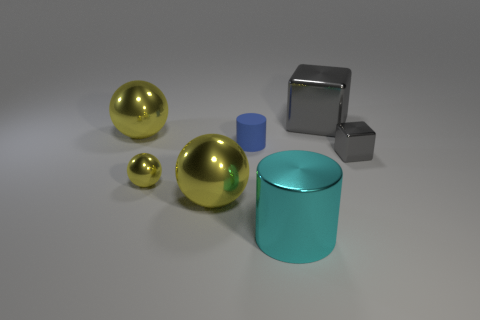What is the color of the cylinder that is made of the same material as the big gray thing?
Keep it short and to the point. Cyan. There is a thing that is the same color as the tiny metallic block; what shape is it?
Ensure brevity in your answer.  Cube. Is the number of tiny blue cylinders that are right of the big cyan shiny object the same as the number of rubber cylinders that are behind the big block?
Make the answer very short. Yes. The metallic thing that is behind the yellow metal ball behind the blue matte object is what shape?
Offer a very short reply. Cube. There is a small object that is the same shape as the big cyan object; what is it made of?
Make the answer very short. Rubber. There is a metallic block that is the same size as the cyan cylinder; what is its color?
Provide a short and direct response. Gray. Are there an equal number of gray metallic things on the left side of the small matte object and cylinders?
Provide a succinct answer. No. What color is the tiny metallic thing behind the tiny yellow object that is in front of the blue matte thing?
Your answer should be very brief. Gray. There is a blue object that is left of the gray object in front of the large gray thing; what size is it?
Your answer should be very brief. Small. What is the size of the shiny thing that is the same color as the tiny cube?
Provide a short and direct response. Large. 